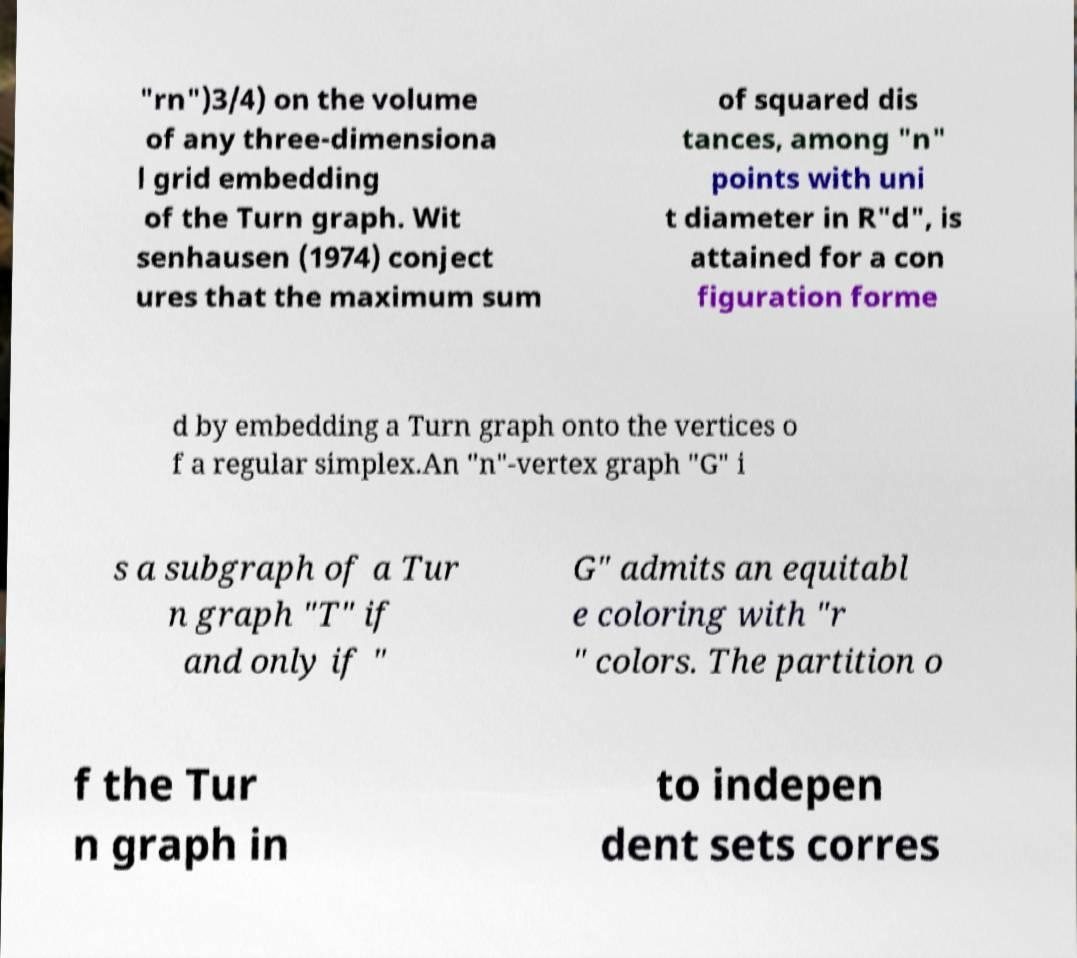I need the written content from this picture converted into text. Can you do that? "rn")3/4) on the volume of any three-dimensiona l grid embedding of the Turn graph. Wit senhausen (1974) conject ures that the maximum sum of squared dis tances, among "n" points with uni t diameter in R"d", is attained for a con figuration forme d by embedding a Turn graph onto the vertices o f a regular simplex.An "n"-vertex graph "G" i s a subgraph of a Tur n graph "T" if and only if " G" admits an equitabl e coloring with "r " colors. The partition o f the Tur n graph in to indepen dent sets corres 